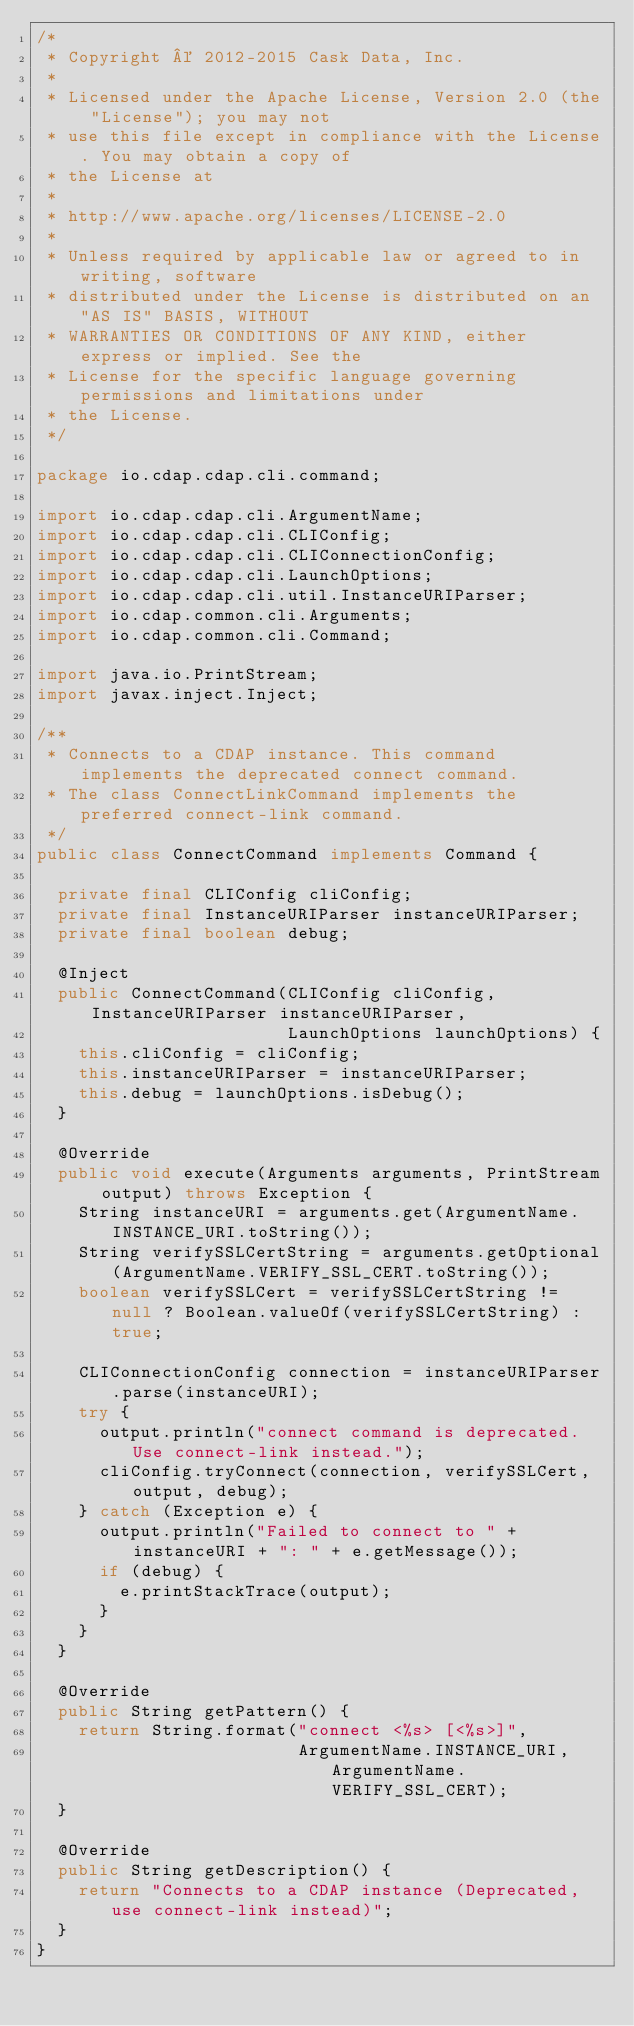<code> <loc_0><loc_0><loc_500><loc_500><_Java_>/*
 * Copyright © 2012-2015 Cask Data, Inc.
 *
 * Licensed under the Apache License, Version 2.0 (the "License"); you may not
 * use this file except in compliance with the License. You may obtain a copy of
 * the License at
 *
 * http://www.apache.org/licenses/LICENSE-2.0
 *
 * Unless required by applicable law or agreed to in writing, software
 * distributed under the License is distributed on an "AS IS" BASIS, WITHOUT
 * WARRANTIES OR CONDITIONS OF ANY KIND, either express or implied. See the
 * License for the specific language governing permissions and limitations under
 * the License.
 */

package io.cdap.cdap.cli.command;

import io.cdap.cdap.cli.ArgumentName;
import io.cdap.cdap.cli.CLIConfig;
import io.cdap.cdap.cli.CLIConnectionConfig;
import io.cdap.cdap.cli.LaunchOptions;
import io.cdap.cdap.cli.util.InstanceURIParser;
import io.cdap.common.cli.Arguments;
import io.cdap.common.cli.Command;

import java.io.PrintStream;
import javax.inject.Inject;

/**
 * Connects to a CDAP instance. This command implements the deprecated connect command.
 * The class ConnectLinkCommand implements the preferred connect-link command.
 */
public class ConnectCommand implements Command {

  private final CLIConfig cliConfig;
  private final InstanceURIParser instanceURIParser;
  private final boolean debug;

  @Inject
  public ConnectCommand(CLIConfig cliConfig, InstanceURIParser instanceURIParser,
                        LaunchOptions launchOptions) {
    this.cliConfig = cliConfig;
    this.instanceURIParser = instanceURIParser;
    this.debug = launchOptions.isDebug();
  }

  @Override
  public void execute(Arguments arguments, PrintStream output) throws Exception {
    String instanceURI = arguments.get(ArgumentName.INSTANCE_URI.toString());
    String verifySSLCertString = arguments.getOptional(ArgumentName.VERIFY_SSL_CERT.toString());
    boolean verifySSLCert = verifySSLCertString != null ? Boolean.valueOf(verifySSLCertString) : true;

    CLIConnectionConfig connection = instanceURIParser.parse(instanceURI);
    try {
      output.println("connect command is deprecated. Use connect-link instead.");
      cliConfig.tryConnect(connection, verifySSLCert, output, debug);
    } catch (Exception e) {
      output.println("Failed to connect to " + instanceURI + ": " + e.getMessage());
      if (debug) {
        e.printStackTrace(output);
      }
    }
  }

  @Override
  public String getPattern() {
    return String.format("connect <%s> [<%s>]",
                         ArgumentName.INSTANCE_URI, ArgumentName.VERIFY_SSL_CERT);
  }

  @Override
  public String getDescription() {
    return "Connects to a CDAP instance (Deprecated, use connect-link instead)";
  }
}
</code> 